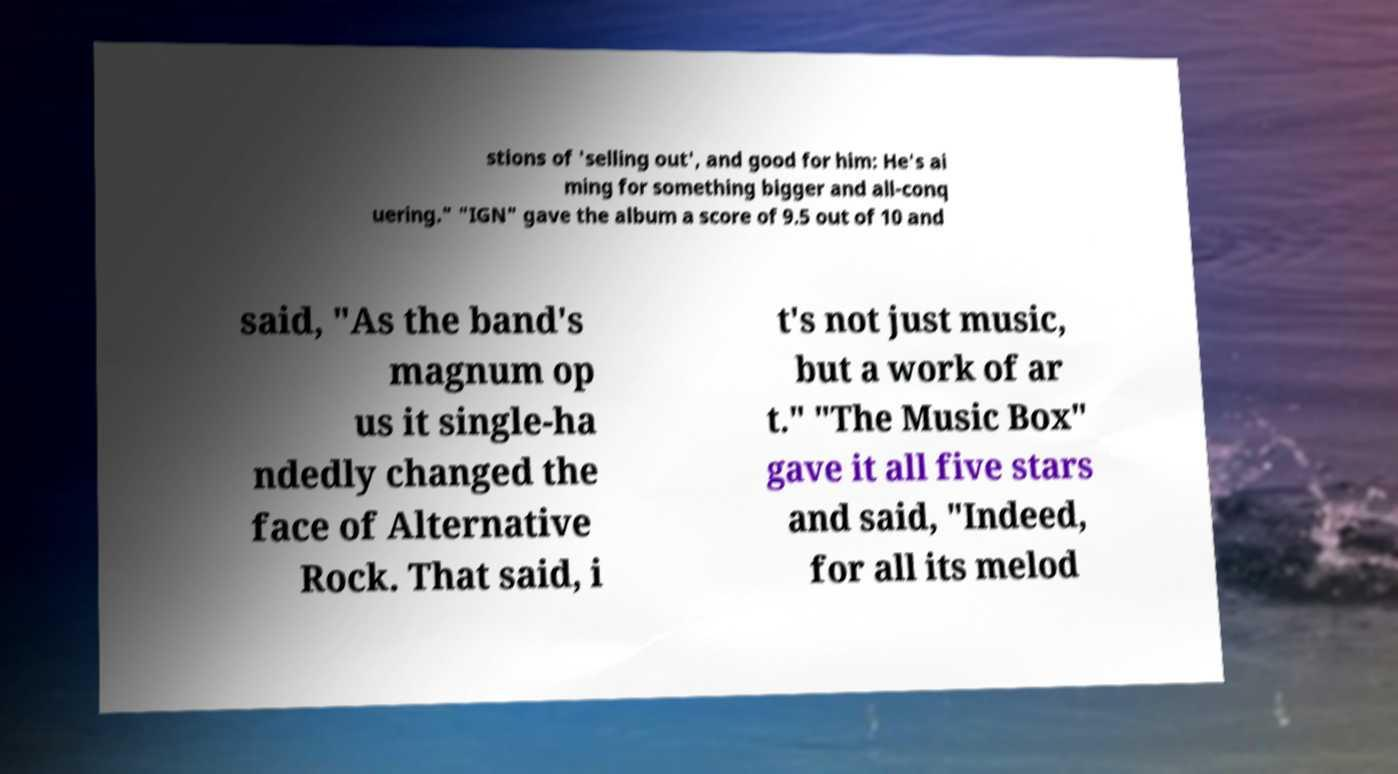Can you read and provide the text displayed in the image?This photo seems to have some interesting text. Can you extract and type it out for me? stions of 'selling out', and good for him: He's ai ming for something bigger and all-conq uering." "IGN" gave the album a score of 9.5 out of 10 and said, "As the band's magnum op us it single-ha ndedly changed the face of Alternative Rock. That said, i t's not just music, but a work of ar t." "The Music Box" gave it all five stars and said, "Indeed, for all its melod 